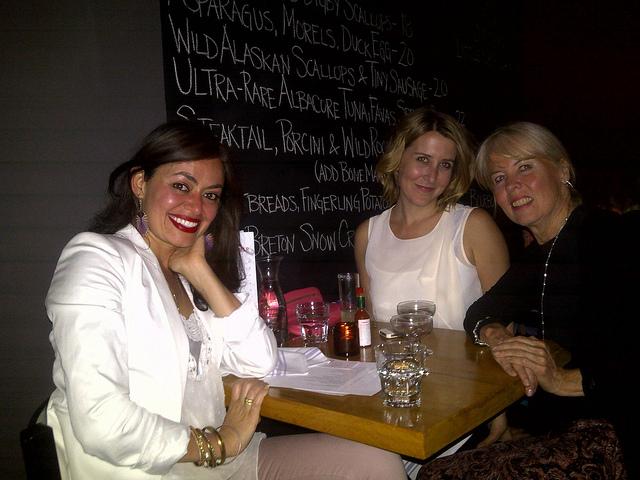Do you see a blonde?
Answer briefly. Yes. What are they probably drinking?
Be succinct. Water. How likely is it this is a ladies' night?
Give a very brief answer. Very. Was this picture likely taken recently?
Give a very brief answer. Yes. Is the their real hair?
Short answer required. Yes. How many women are there?
Concise answer only. 3. Is the bride wearing a strapless gown?
Write a very short answer. No. What type of glasses are on the table?
Quick response, please. Water. What time is it on her watch?
Answer briefly. 12:00. How many men are here?
Keep it brief. 0. Are both of the women blonde?
Answer briefly. Yes. What does it say on the glass in her left hand?
Answer briefly. Nothing. Is she playing Wii?
Give a very brief answer. No. Are scallops on the menu?
Short answer required. Yes. What are they drinking?
Quick response, please. Water. What are they celebrating?
Write a very short answer. Birthday. Are any lights on?
Answer briefly. Yes. What are the women doing in the picture?
Quick response, please. Smiling. What word is behind the woman?
Be succinct. Ultra. Are these people eating?
Answer briefly. No. Which lady is the oldest?
Short answer required. Right. What are the couple standing in front of?
Write a very short answer. Table. 